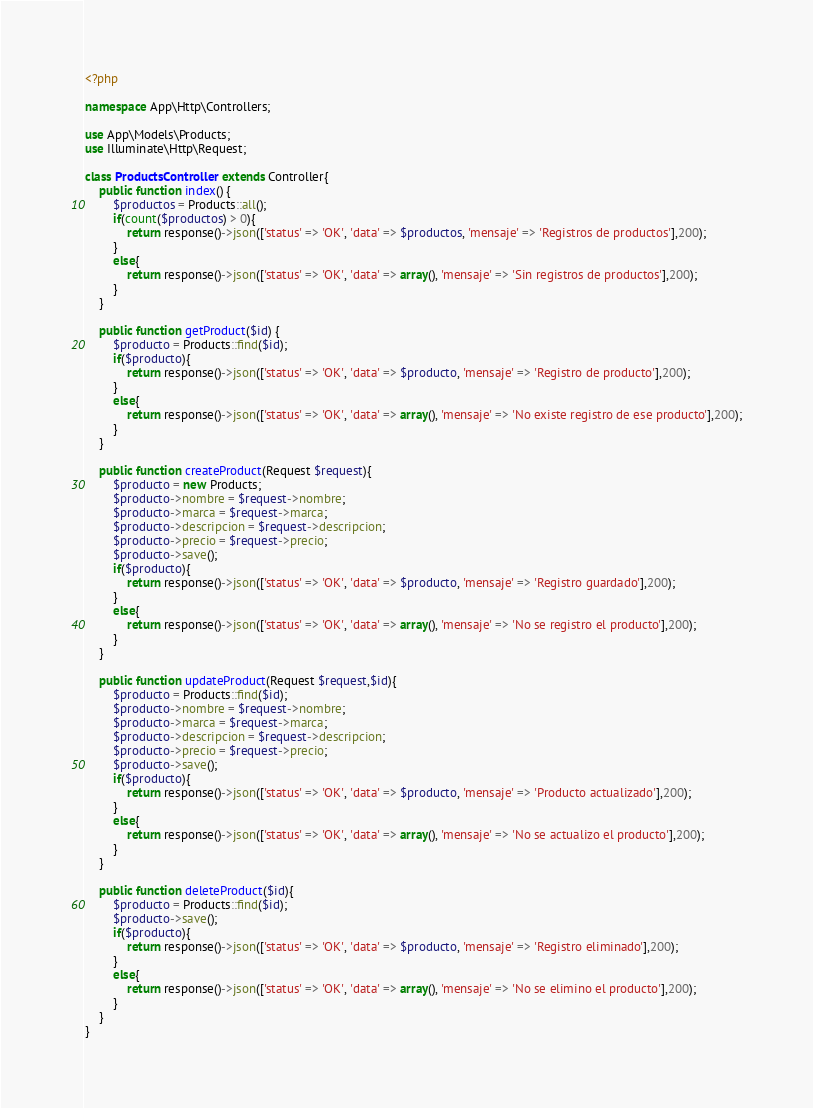Convert code to text. <code><loc_0><loc_0><loc_500><loc_500><_PHP_><?php

namespace App\Http\Controllers;

use App\Models\Products;
use Illuminate\Http\Request;

class ProductsController extends Controller{
    public function index() {
        $productos = Products::all();
        if(count($productos) > 0){
            return response()->json(['status' => 'OK', 'data' => $productos, 'mensaje' => 'Registros de productos'],200);
        }
        else{
            return response()->json(['status' => 'OK', 'data' => array(), 'mensaje' => 'Sin registros de productos'],200);
        }
    }

    public function getProduct($id) {
        $producto = Products::find($id);
        if($producto){
            return response()->json(['status' => 'OK', 'data' => $producto, 'mensaje' => 'Registro de producto'],200);
        }
        else{
            return response()->json(['status' => 'OK', 'data' => array(), 'mensaje' => 'No existe registro de ese producto'],200);
        }
    }

    public function createProduct(Request $request){
        $producto = new Products;
        $producto->nombre = $request->nombre;
        $producto->marca = $request->marca;
        $producto->descripcion = $request->descripcion;
        $producto->precio = $request->precio;
        $producto->save();
        if($producto){
            return response()->json(['status' => 'OK', 'data' => $producto, 'mensaje' => 'Registro guardado'],200);
        }
        else{
            return response()->json(['status' => 'OK', 'data' => array(), 'mensaje' => 'No se registro el producto'],200);
        }
    }

    public function updateProduct(Request $request,$id){
        $producto = Products::find($id);
        $producto->nombre = $request->nombre;
        $producto->marca = $request->marca;
        $producto->descripcion = $request->descripcion;
        $producto->precio = $request->precio;
        $producto->save();
        if($producto){
            return response()->json(['status' => 'OK', 'data' => $producto, 'mensaje' => 'Producto actualizado'],200);
        }
        else{
            return response()->json(['status' => 'OK', 'data' => array(), 'mensaje' => 'No se actualizo el producto'],200);
        }
    }

    public function deleteProduct($id){
        $producto = Products::find($id);
        $producto->save();
        if($producto){
            return response()->json(['status' => 'OK', 'data' => $producto, 'mensaje' => 'Registro eliminado'],200);
        }
        else{
            return response()->json(['status' => 'OK', 'data' => array(), 'mensaje' => 'No se elimino el producto'],200);
        }
    }
}
</code> 